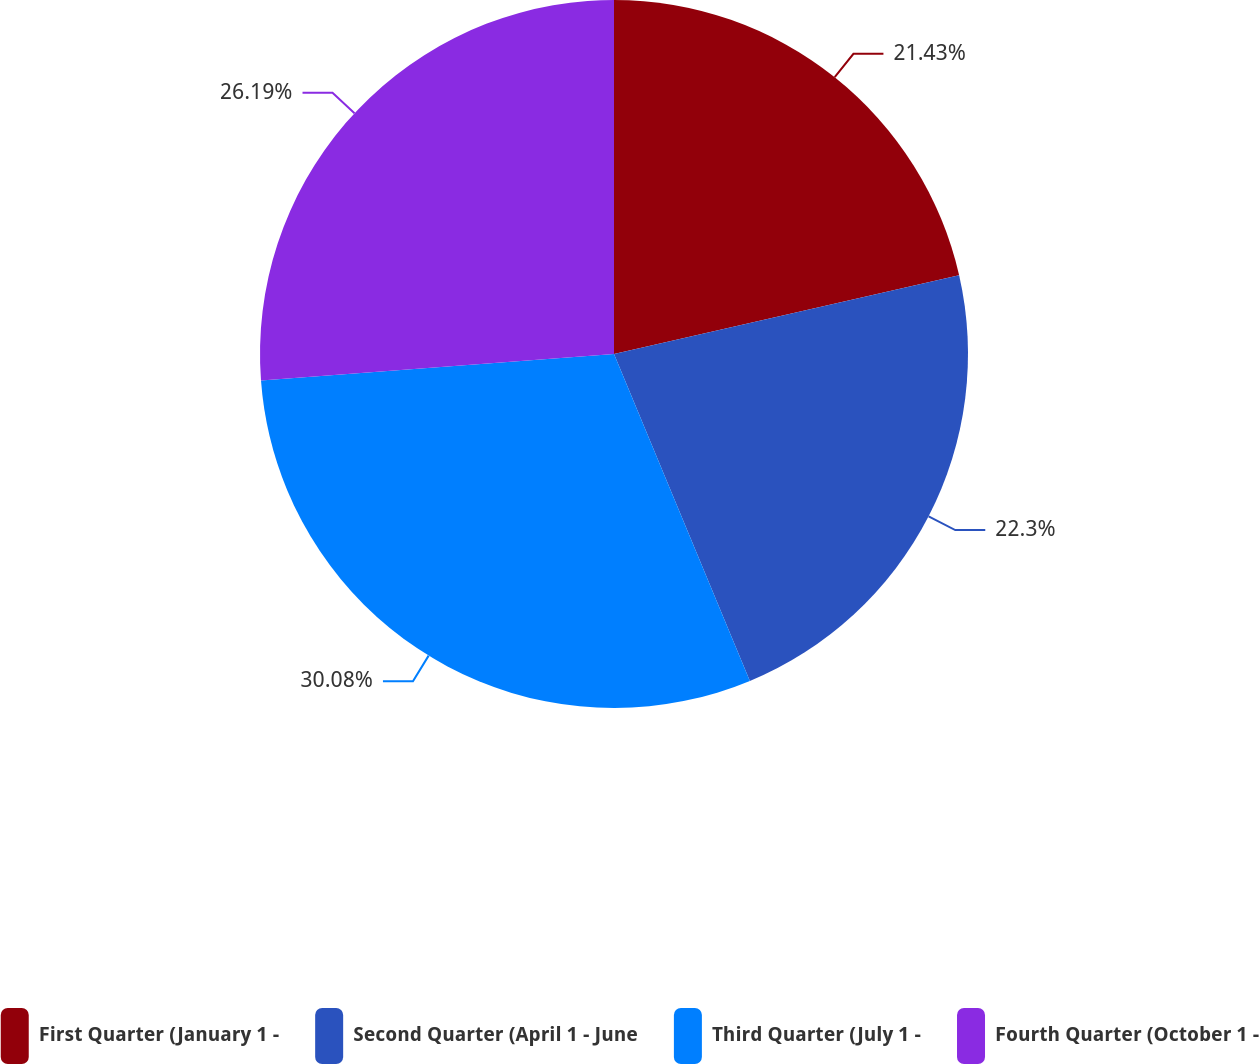Convert chart. <chart><loc_0><loc_0><loc_500><loc_500><pie_chart><fcel>First Quarter (January 1 -<fcel>Second Quarter (April 1 - June<fcel>Third Quarter (July 1 -<fcel>Fourth Quarter (October 1 -<nl><fcel>21.43%<fcel>22.3%<fcel>30.08%<fcel>26.19%<nl></chart> 